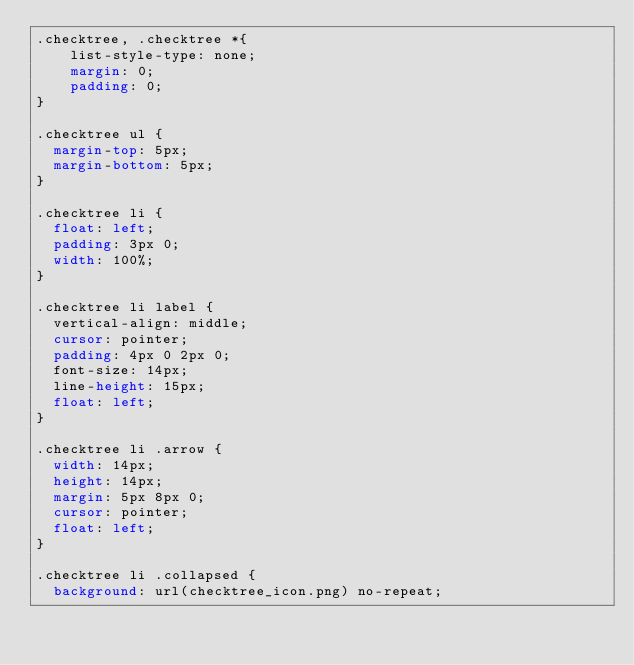Convert code to text. <code><loc_0><loc_0><loc_500><loc_500><_CSS_>.checktree, .checktree *{
    list-style-type: none;
    margin: 0;
    padding: 0;
}

.checktree ul {
  margin-top: 5px;
  margin-bottom: 5px;
}

.checktree li {
  float: left;
  padding: 3px 0;
  width: 100%;
}

.checktree li label {
  vertical-align: middle;
  cursor: pointer;
  padding: 4px 0 2px 0;
  font-size: 14px;
  line-height: 15px;
  float: left;
}

.checktree li .arrow {
  width: 14px;
  height: 14px;
  margin: 5px 8px 0;
  cursor: pointer;
  float: left;
}

.checktree li .collapsed {
  background: url(checktree_icon.png) no-repeat;</code> 